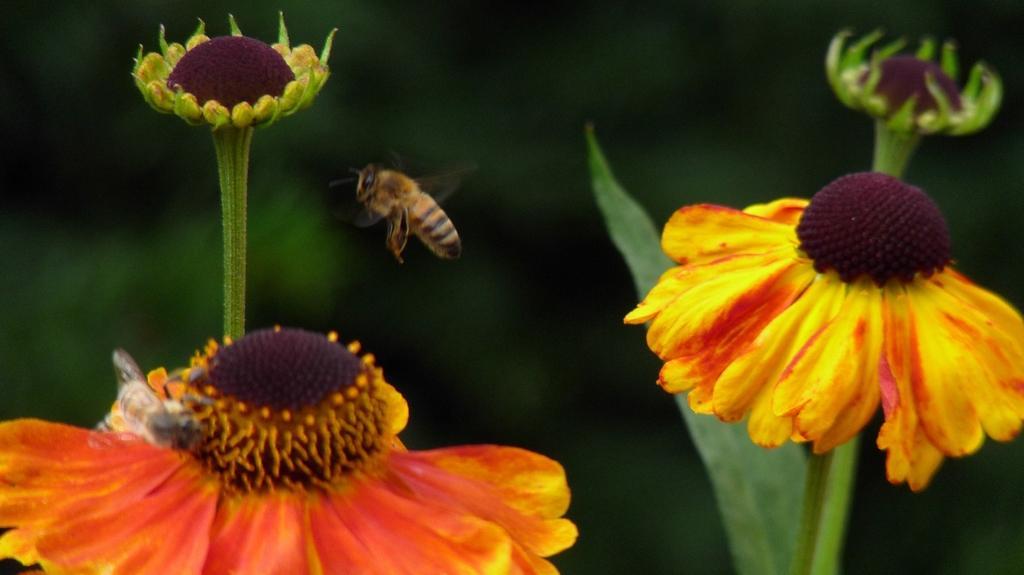Could you give a brief overview of what you see in this image? In this image, we can see some flowers. There is a bee in the middle of the image. In the background, image is blurred. 